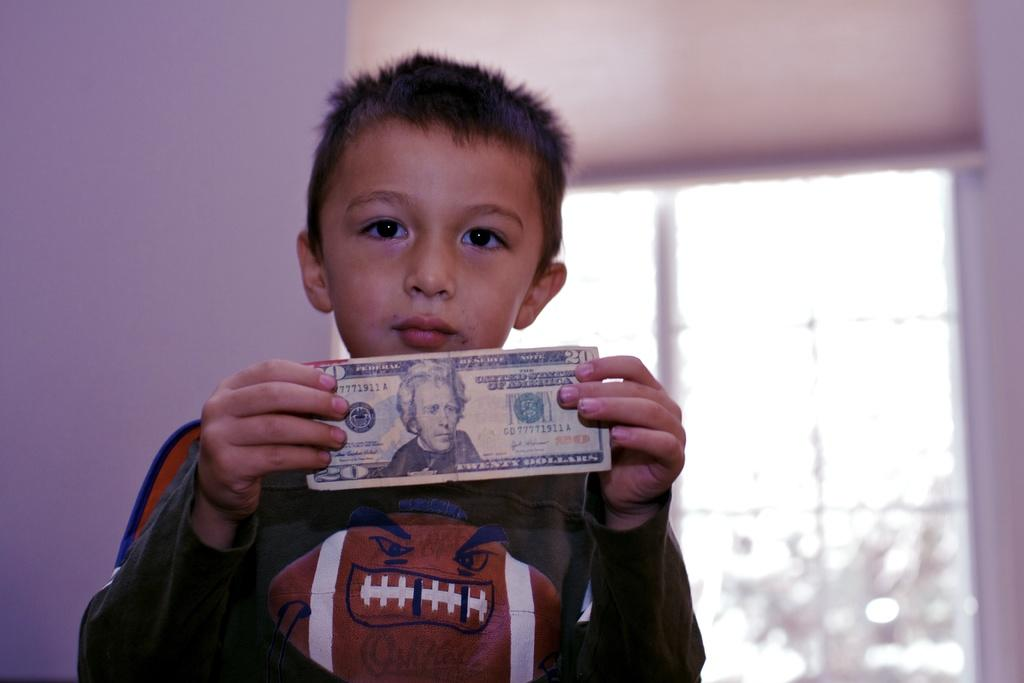<image>
Offer a succinct explanation of the picture presented. a boy that is holding a 20 dollar bill 